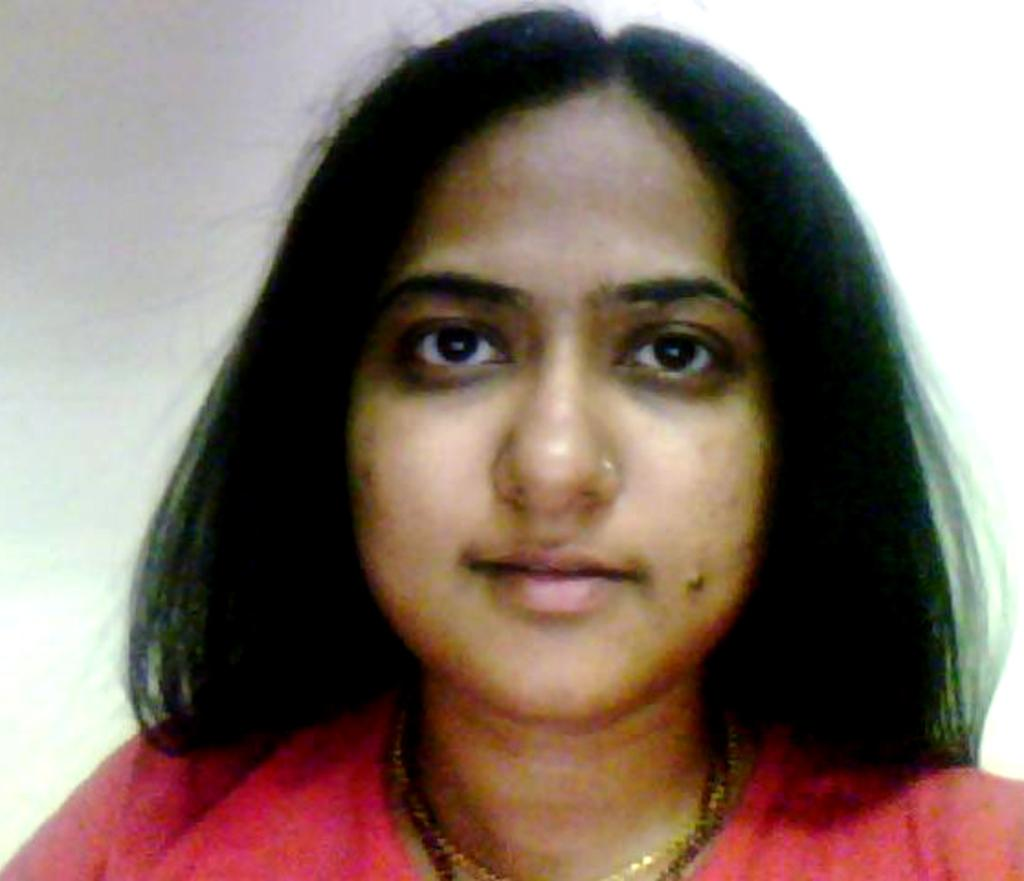Who is the main subject in the image? There is a lady in the image. What can be seen behind the lady in the image? The background of the image is white. How many trees are visible in the image? There are no trees visible in the image, as the background is white. What type of flesh can be seen on the lady's arm in the image? There is no flesh visible on the lady's arm in the image, as the focus is on the lady and the white background. 